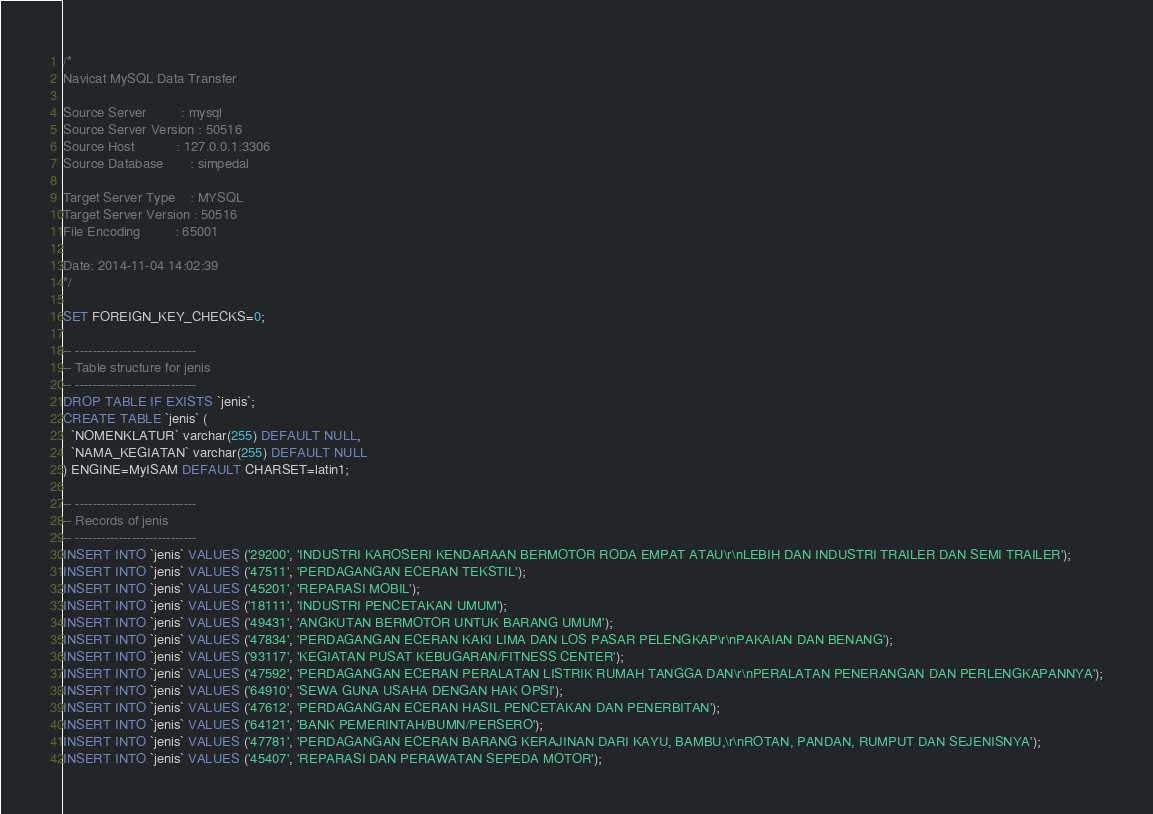Convert code to text. <code><loc_0><loc_0><loc_500><loc_500><_SQL_>/*
Navicat MySQL Data Transfer

Source Server         : mysql
Source Server Version : 50516
Source Host           : 127.0.0.1:3306
Source Database       : simpedal

Target Server Type    : MYSQL
Target Server Version : 50516
File Encoding         : 65001

Date: 2014-11-04 14:02:39
*/

SET FOREIGN_KEY_CHECKS=0;

-- ----------------------------
-- Table structure for jenis
-- ----------------------------
DROP TABLE IF EXISTS `jenis`;
CREATE TABLE `jenis` (
  `NOMENKLATUR` varchar(255) DEFAULT NULL,
  `NAMA_KEGIATAN` varchar(255) DEFAULT NULL
) ENGINE=MyISAM DEFAULT CHARSET=latin1;

-- ----------------------------
-- Records of jenis
-- ----------------------------
INSERT INTO `jenis` VALUES ('29200', 'INDUSTRI KAROSERI KENDARAAN BERMOTOR RODA EMPAT ATAU\r\nLEBIH DAN INDUSTRI TRAILER DAN SEMI TRAILER');
INSERT INTO `jenis` VALUES ('47511', 'PERDAGANGAN ECERAN TEKSTIL');
INSERT INTO `jenis` VALUES ('45201', 'REPARASI MOBIL');
INSERT INTO `jenis` VALUES ('18111', 'INDUSTRI PENCETAKAN UMUM');
INSERT INTO `jenis` VALUES ('49431', 'ANGKUTAN BERMOTOR UNTUK BARANG UMUM');
INSERT INTO `jenis` VALUES ('47834', 'PERDAGANGAN ECERAN KAKI LIMA DAN LOS PASAR PELENGKAP\r\nPAKAIAN DAN BENANG');
INSERT INTO `jenis` VALUES ('93117', 'KEGIATAN PUSAT KEBUGARAN/FITNESS CENTER');
INSERT INTO `jenis` VALUES ('47592', 'PERDAGANGAN ECERAN PERALATAN LISTRIK RUMAH TANGGA DAN\r\nPERALATAN PENERANGAN DAN PERLENGKAPANNYA');
INSERT INTO `jenis` VALUES ('64910', 'SEWA GUNA USAHA DENGAN HAK OPSI');
INSERT INTO `jenis` VALUES ('47612', 'PERDAGANGAN ECERAN HASIL PENCETAKAN DAN PENERBITAN');
INSERT INTO `jenis` VALUES ('64121', 'BANK PEMERINTAH/BUMN/PERSERO');
INSERT INTO `jenis` VALUES ('47781', 'PERDAGANGAN ECERAN BARANG KERAJINAN DARI KAYU, BAMBU,\r\nROTAN, PANDAN, RUMPUT DAN SEJENISNYA');
INSERT INTO `jenis` VALUES ('45407', 'REPARASI DAN PERAWATAN SEPEDA MOTOR');</code> 